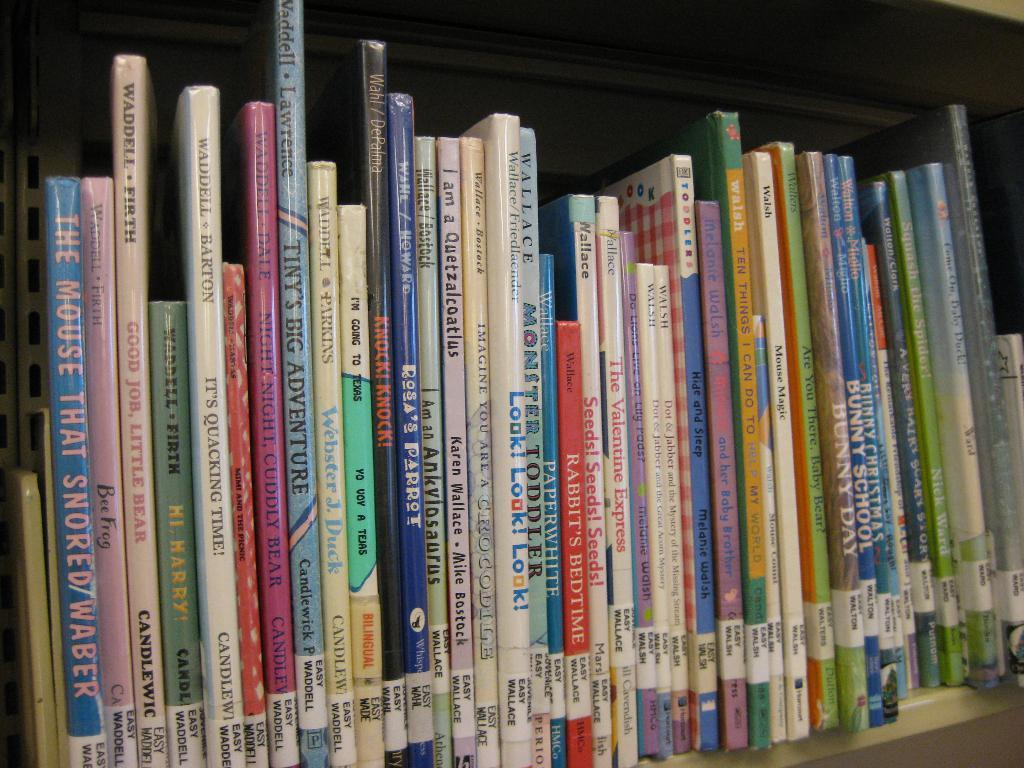<image>
Offer a succinct explanation of the picture presented. books lined up on a library bookshelf include Look Look Look! 